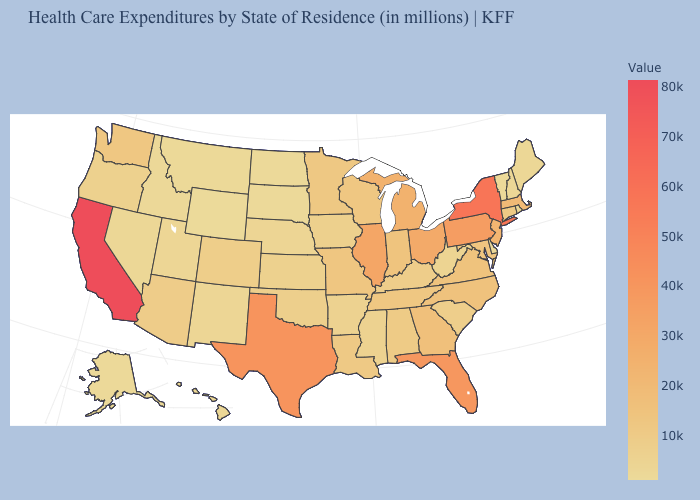Which states have the highest value in the USA?
Be succinct. California. Which states have the highest value in the USA?
Be succinct. California. Which states have the lowest value in the USA?
Write a very short answer. Wyoming. Which states have the lowest value in the MidWest?
Short answer required. South Dakota. 